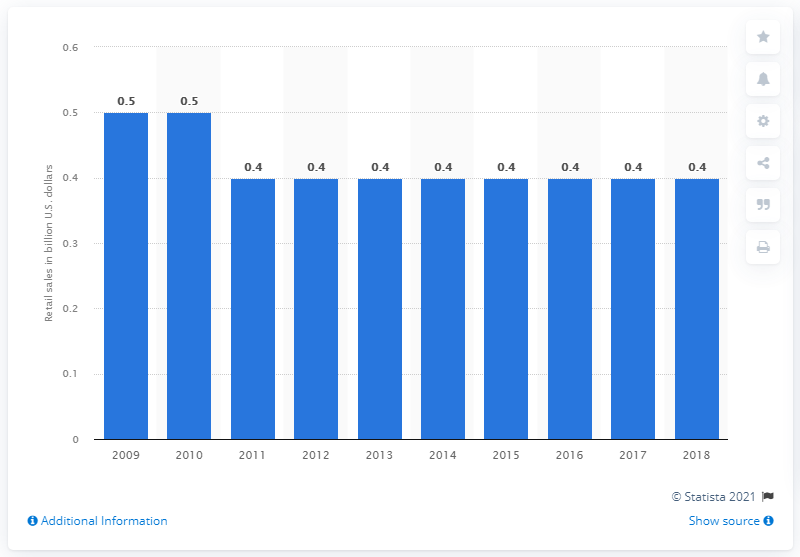List a handful of essential elements in this visual. In 2018, the retail sales of chewing gum in Canada were approximately CAD 0.4 billion. 